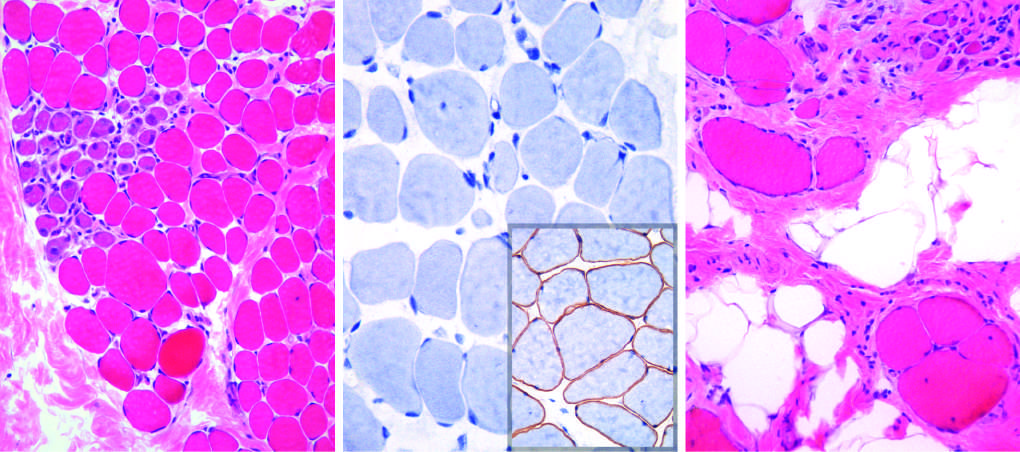do the normal areas dna content and the zygosity plot show variation in size?
Answer the question using a single word or phrase. No 